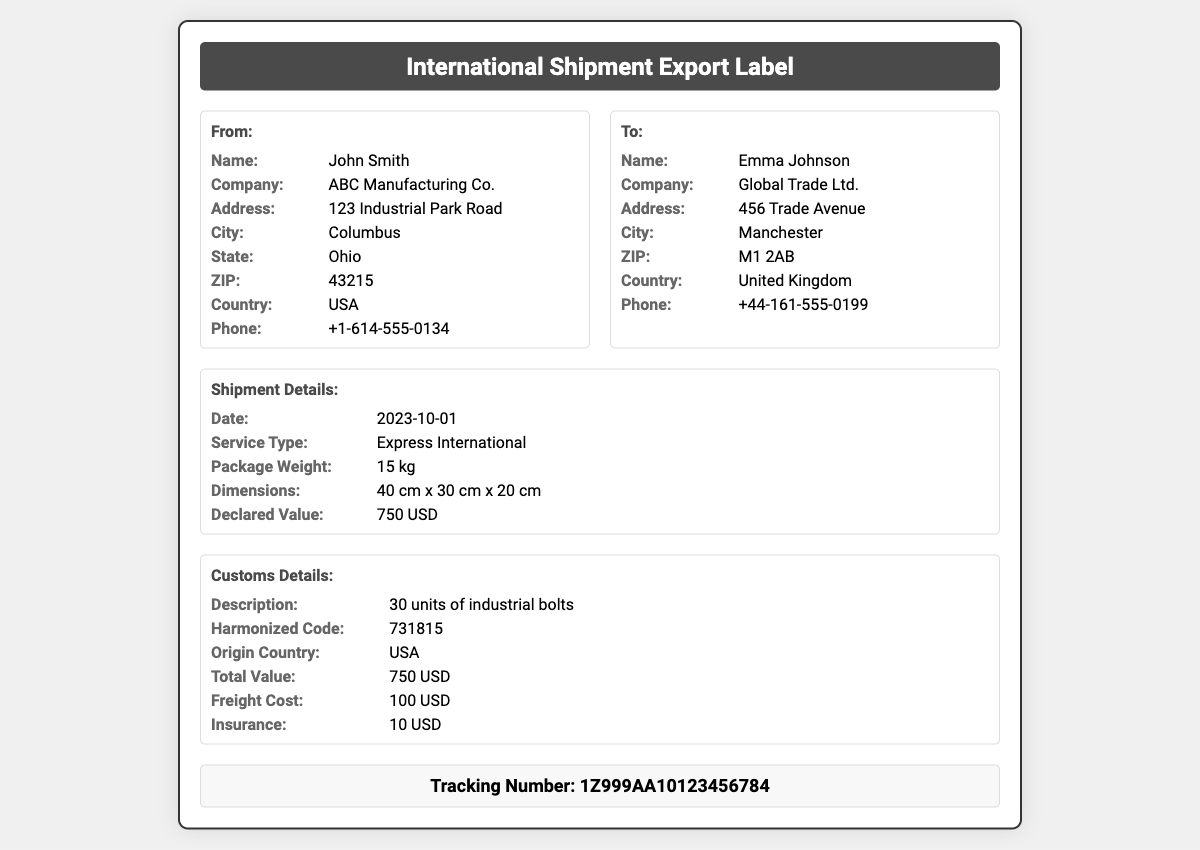What is the sender's name? The sender's name listed in the document is John Smith.
Answer: John Smith What is the recipient's country? The recipient's country is mentioned as United Kingdom.
Answer: United Kingdom What is the declared value of the shipment? The declared value is specified in the document as 750 USD.
Answer: 750 USD What is the tracking number? The tracking number provided is 1Z999AA10123456784.
Answer: 1Z999AA10123456784 How many units are being shipped? The document states that there are 30 units of industrial bolts being shipped.
Answer: 30 units What is the total value including declared value, freight cost, and insurance? The total value is calculated as declared value plus freight cost and insurance: 750 USD + 100 USD + 10 USD = 860 USD.
Answer: 860 USD What type of service is used for shipment? The type of service indicated in the document is Express International.
Answer: Express International What is the weight of the package? The document specifies the package weight as 15 kg.
Answer: 15 kg 